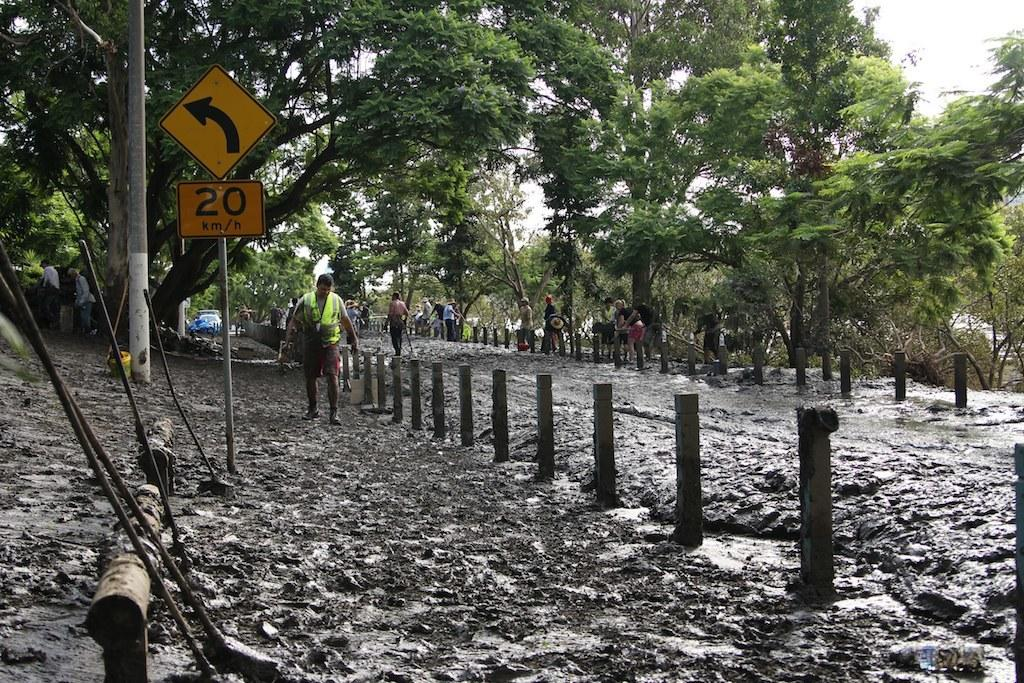What is the main object in the image? There is a sign board in the image. What can be seen in the background of the image? There are trees in the background of the image. What is the ground made of in the image? There is mud visible at the bottom of the image. What are the people in the image doing? There are people walking in the image. What type of linen is draped over the sign board in the image? There is no linen present in the image; the sign board is not covered by any fabric. 